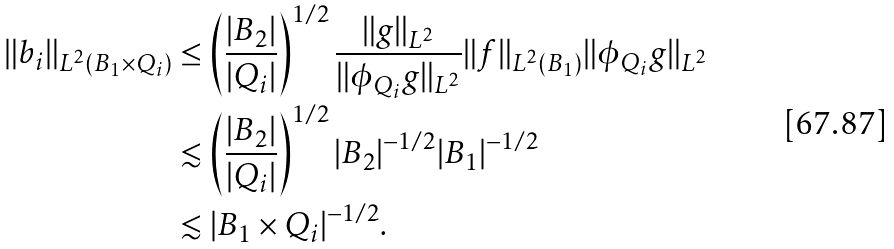Convert formula to latex. <formula><loc_0><loc_0><loc_500><loc_500>\| b _ { i } \| _ { L ^ { 2 } ( B _ { 1 } \times Q _ { i } ) } & \leq \left ( \frac { | B _ { 2 } | } { | Q _ { i } | } \right ) ^ { 1 / 2 } \frac { \| g \| _ { L ^ { 2 } } } { \| \phi _ { Q _ { i } } g \| _ { L ^ { 2 } } } \| f \| _ { L ^ { 2 } ( B _ { 1 } ) } \| \phi _ { Q _ { i } } g \| _ { L ^ { 2 } } \\ & \lesssim \left ( \frac { | B _ { 2 } | } { | Q _ { i } | } \right ) ^ { 1 / 2 } | B _ { 2 } | ^ { - 1 / 2 } | B _ { 1 } | ^ { - 1 / 2 } \\ & \lesssim | B _ { 1 } \times Q _ { i } | ^ { - 1 / 2 } .</formula> 